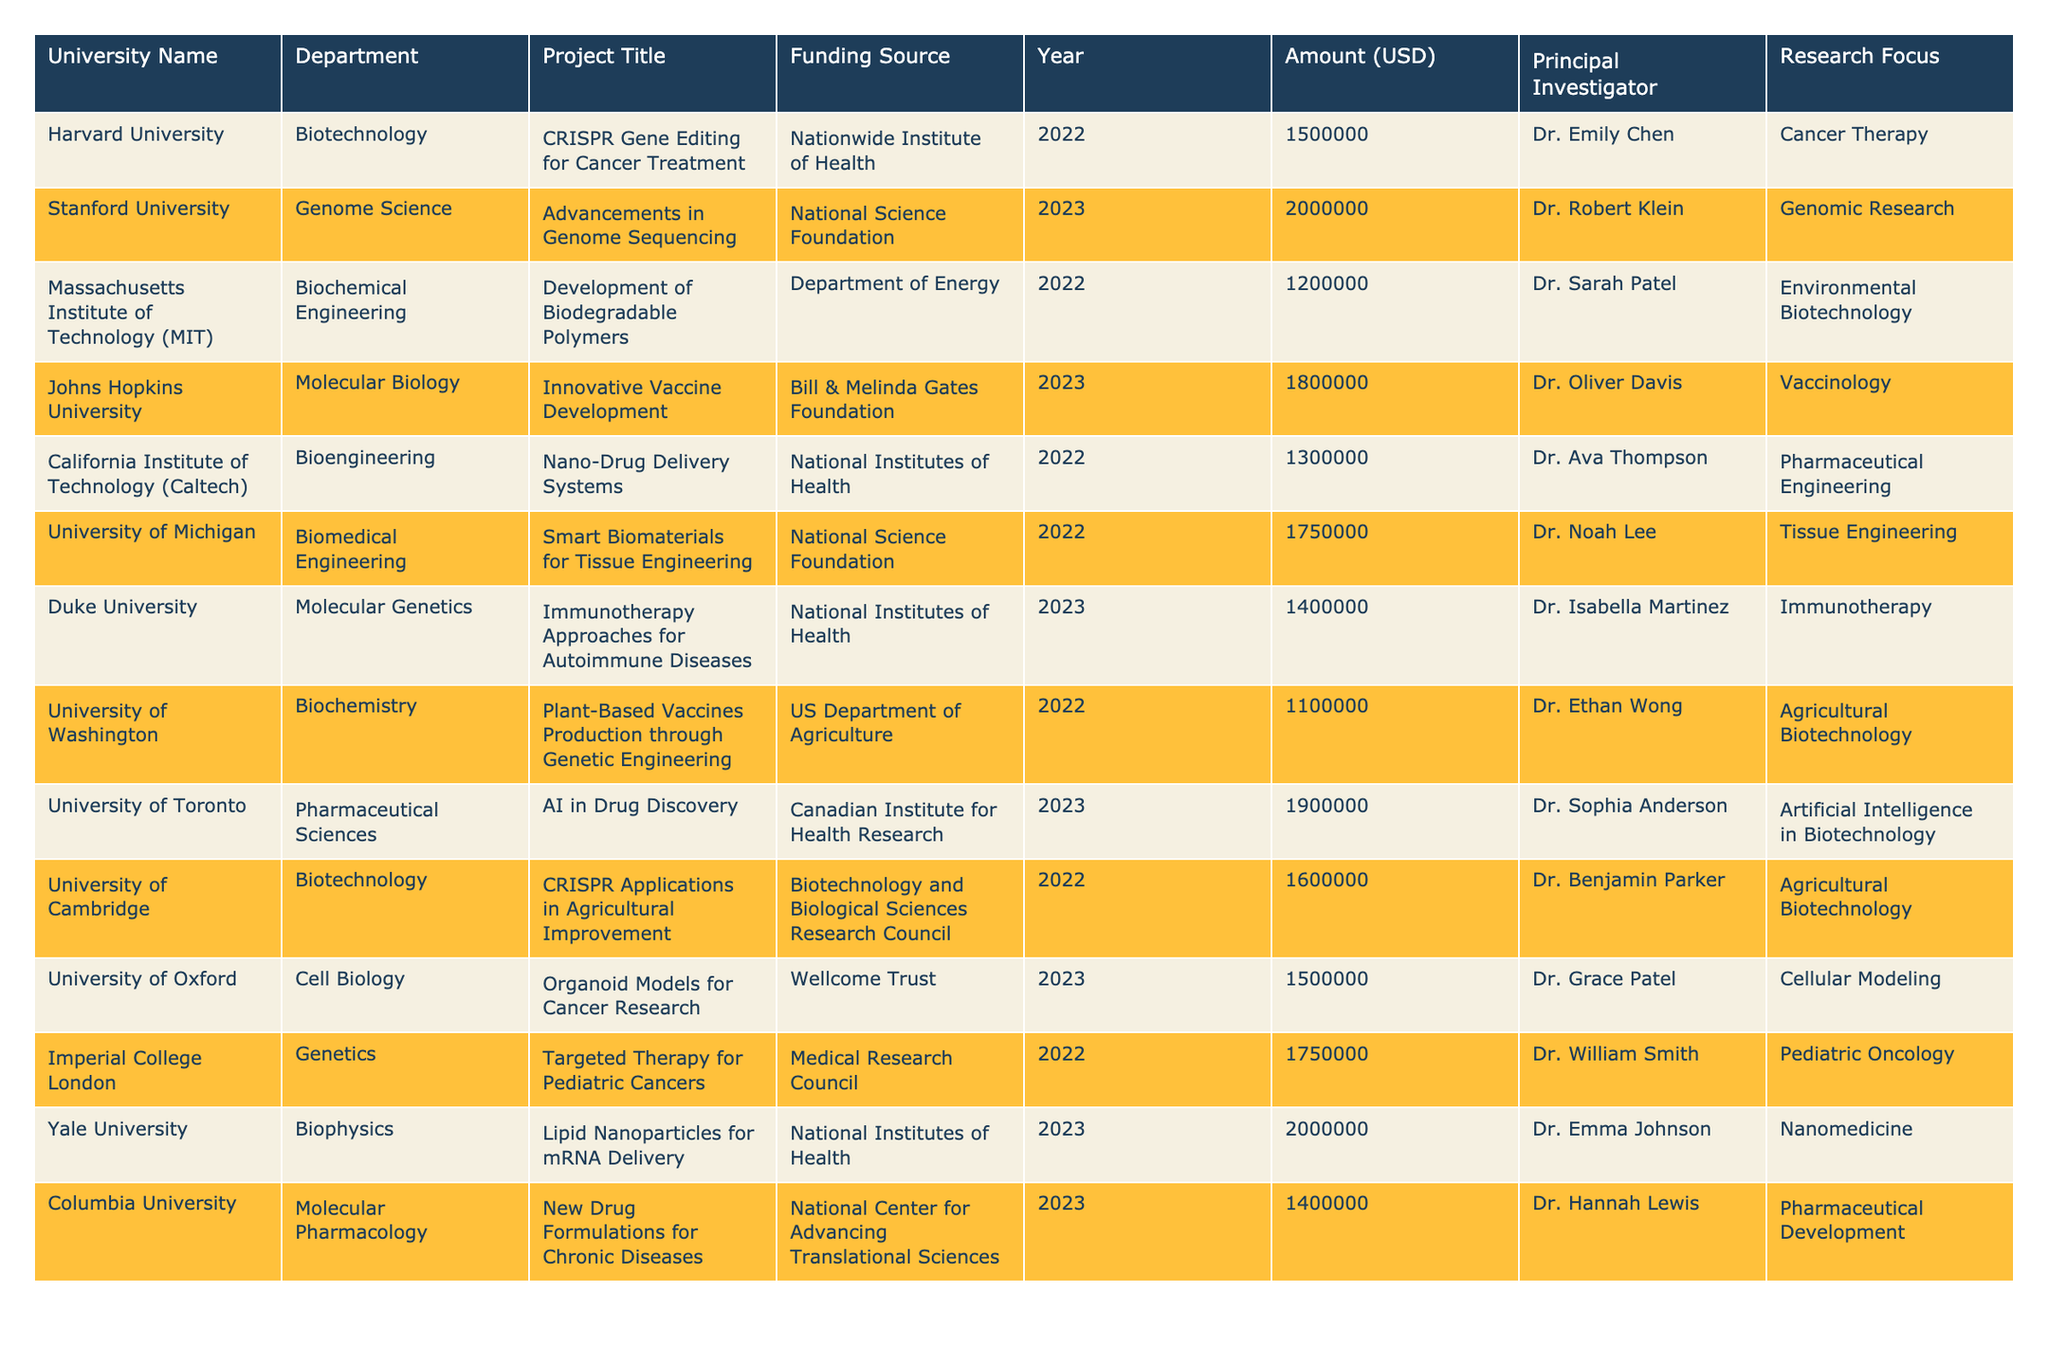What is the total funding allocated to projects at Stanford University? The table shows that the Stanford University project has a funding amount of 2,000,000 USD for the year 2023. Since there is only one project listed for Stanford University, the total funding is simply that single amount.
Answer: 2,000,000 USD Which university received funding for a project focused on "Cancer Therapy"? Referring to the table, Harvard University is listed as receiving funding for the project titled "CRISPR Gene Editing for Cancer Treatment," which focuses on cancer therapy.
Answer: Harvard University What is the average funding amount for projects in 2022? The funding amounts for 2022 are: 1,500,000 (Harvard), 1,200,000 (MIT), 1,300,000 (Caltech), 1,750,000 (University of Michigan), and 1,750,000 (Imperial College London). Adding these amounts gives a total of 7,500,000. There are 5 projects for 2022, so the average funding amount is 7,500,000 / 5 = 1,500,000.
Answer: 1,500,000 USD Which funding source contributed the highest amount to any project and what was the project? Looking through the table for the highest funding amount, we see that the National Science Foundation contributed 2,000,000 USD for the project "Advancements in Genome Sequencing" at Stanford University, which is the highest.
Answer: National Science Foundation, "Advancements in Genome Sequencing" at Stanford University How many projects received funding from the National Institutes of Health? The table lists two projects that received funding from the National Institutes of Health: "Nano-Drug Delivery Systems" from Caltech and "Immunotherapy Approaches for Autoimmune Diseases" from Duke University. Therefore, there are 2 projects.
Answer: 2 projects Was any project in 2023 focused on "Artificial Intelligence in Biotechnology"? The table shows that the University of Toronto’s project titled "AI in Drug Discovery" received funding in 2023, which focuses on artificial intelligence in biotechnology. Therefore, the answer is yes.
Answer: Yes What is the difference in funding between the highest and lowest funded projects in 2023? In 2023, the highest funded project is Yale University with 2,000,000 USD for "Lipid Nanoparticles for mRNA Delivery," and the lowest funded project is Columbia University with 1,400,000 USD for "New Drug Formulations for Chronic Diseases." The difference is 2,000,000 - 1,400,000 = 600,000 USD.
Answer: 600,000 USD Which department at Harvard University received funding and what was the amount? The table indicates that the department at Harvard University is Biotechnology, and it received 1,500,000 USD for the project "CRISPR Gene Editing for Cancer Treatment."
Answer: Biotechnology, 1,500,000 USD Count how many projects focus on "Agricultural Biotechnology" and identify them. The table shows two projects focused on agricultural biotechnology: "Plant-Based Vaccines Production through Genetic Engineering" at University of Washington and "CRISPR Applications in Agricultural Improvement" at University of Cambridge. Therefore, there are 2 projects in this category.
Answer: 2 projects: University of Washington and University of Cambridge Which principal investigator secured funding for the project related to "Vaccinology"? Referring to the table, the project related to vaccinology is "Innovative Vaccine Development" at Johns Hopkins University, and it is led by Dr. Oliver Davis.
Answer: Dr. Oliver Davis 